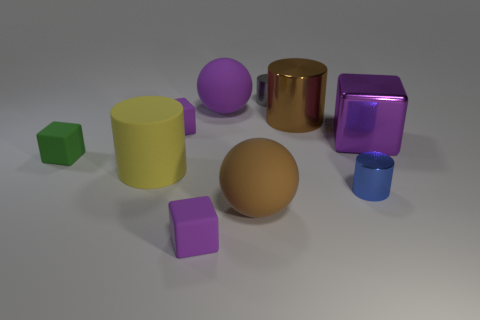How many purple blocks must be subtracted to get 1 purple blocks? 2 Subtract all tiny matte blocks. How many blocks are left? 1 Subtract all blocks. How many objects are left? 6 Subtract 3 cylinders. How many cylinders are left? 1 Subtract all metallic cylinders. Subtract all tiny gray rubber blocks. How many objects are left? 7 Add 3 rubber cylinders. How many rubber cylinders are left? 4 Add 1 big purple rubber spheres. How many big purple rubber spheres exist? 2 Subtract all green blocks. How many blocks are left? 3 Subtract 0 gray spheres. How many objects are left? 10 Subtract all purple blocks. Subtract all blue cylinders. How many blocks are left? 1 